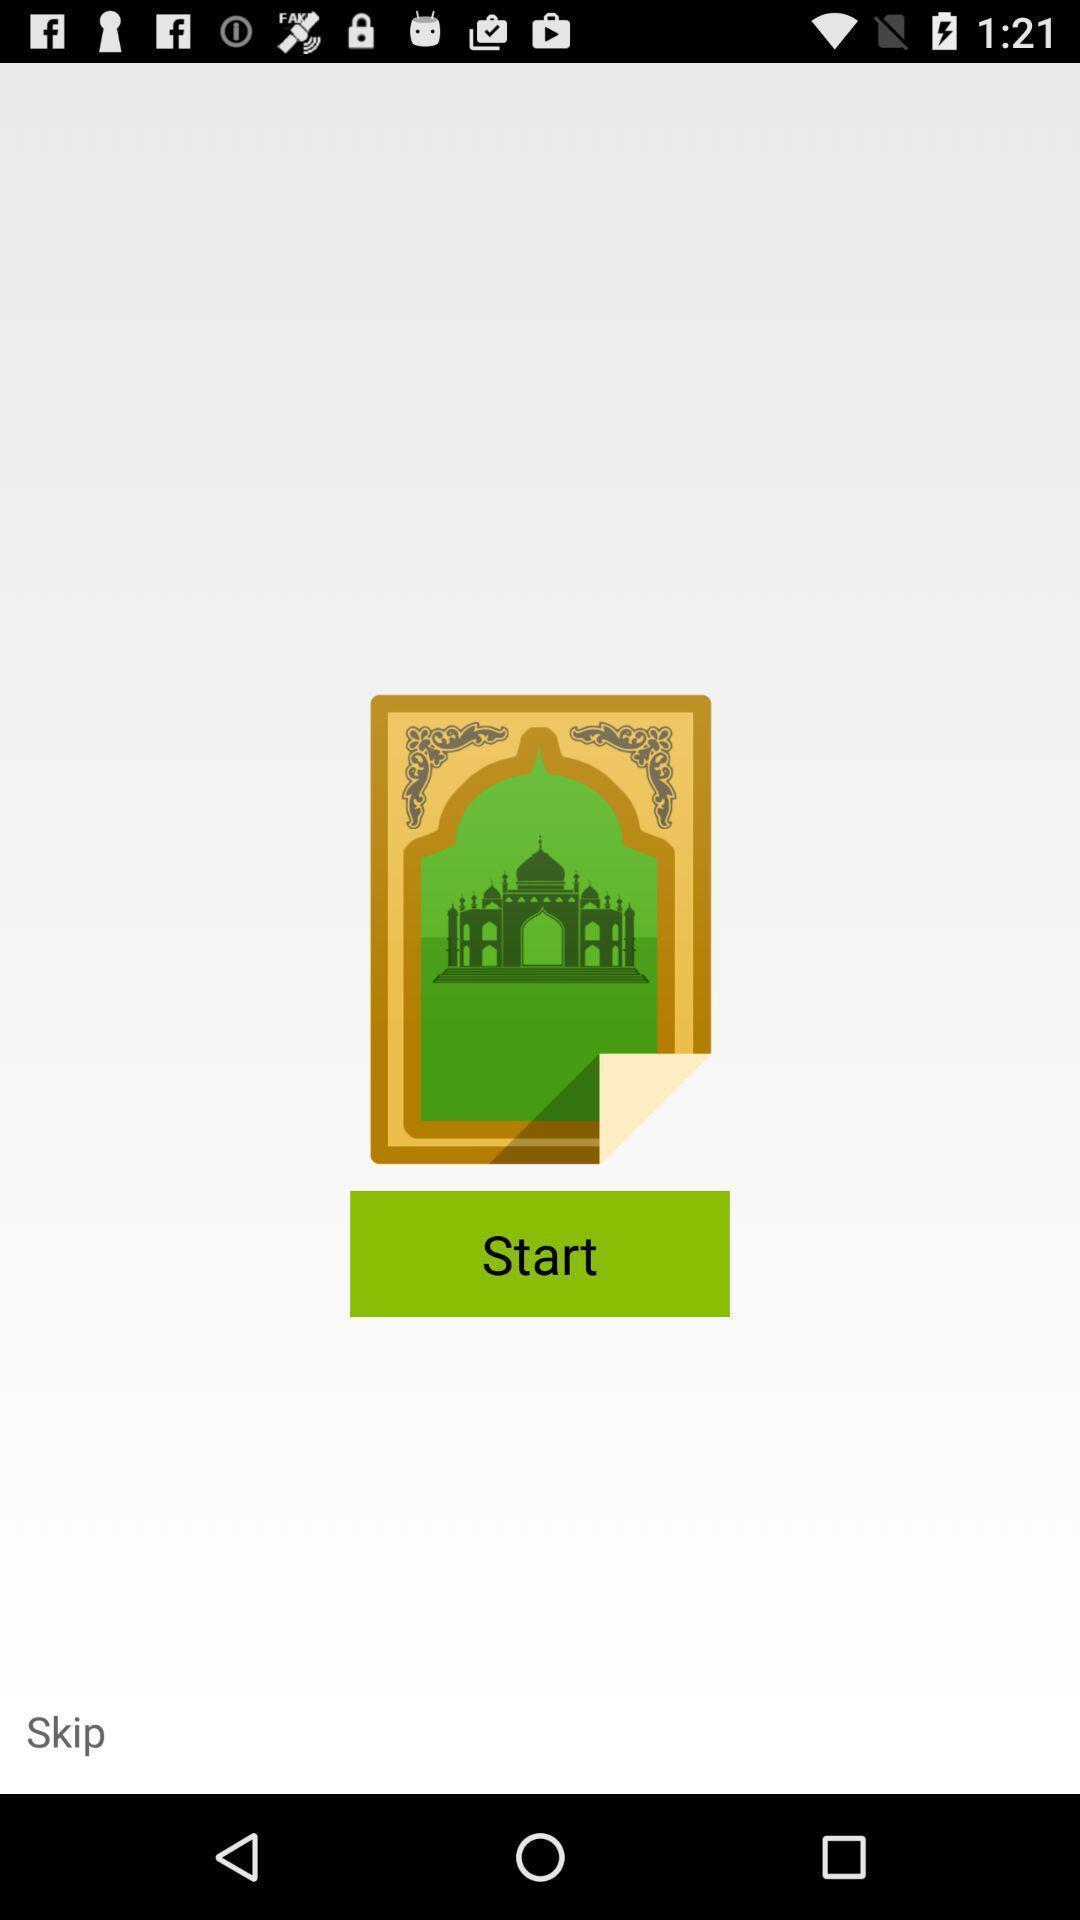Summarize the main components in this picture. Starting page. 